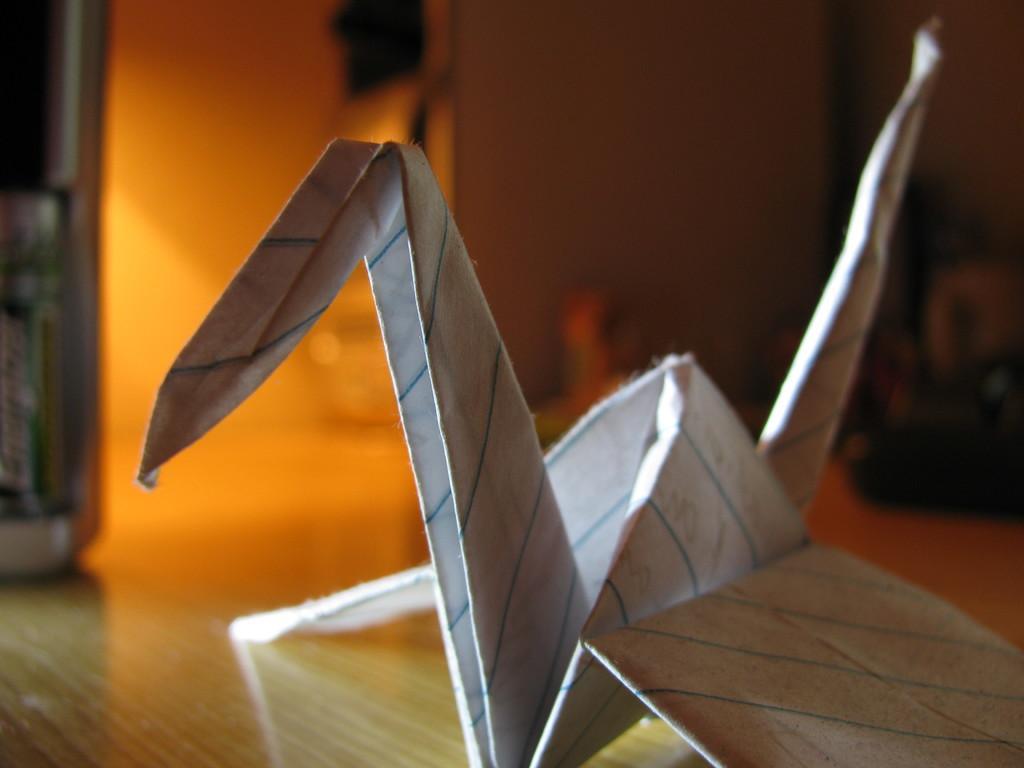Describe this image in one or two sentences. There is a paper craft on a wooden surface. 